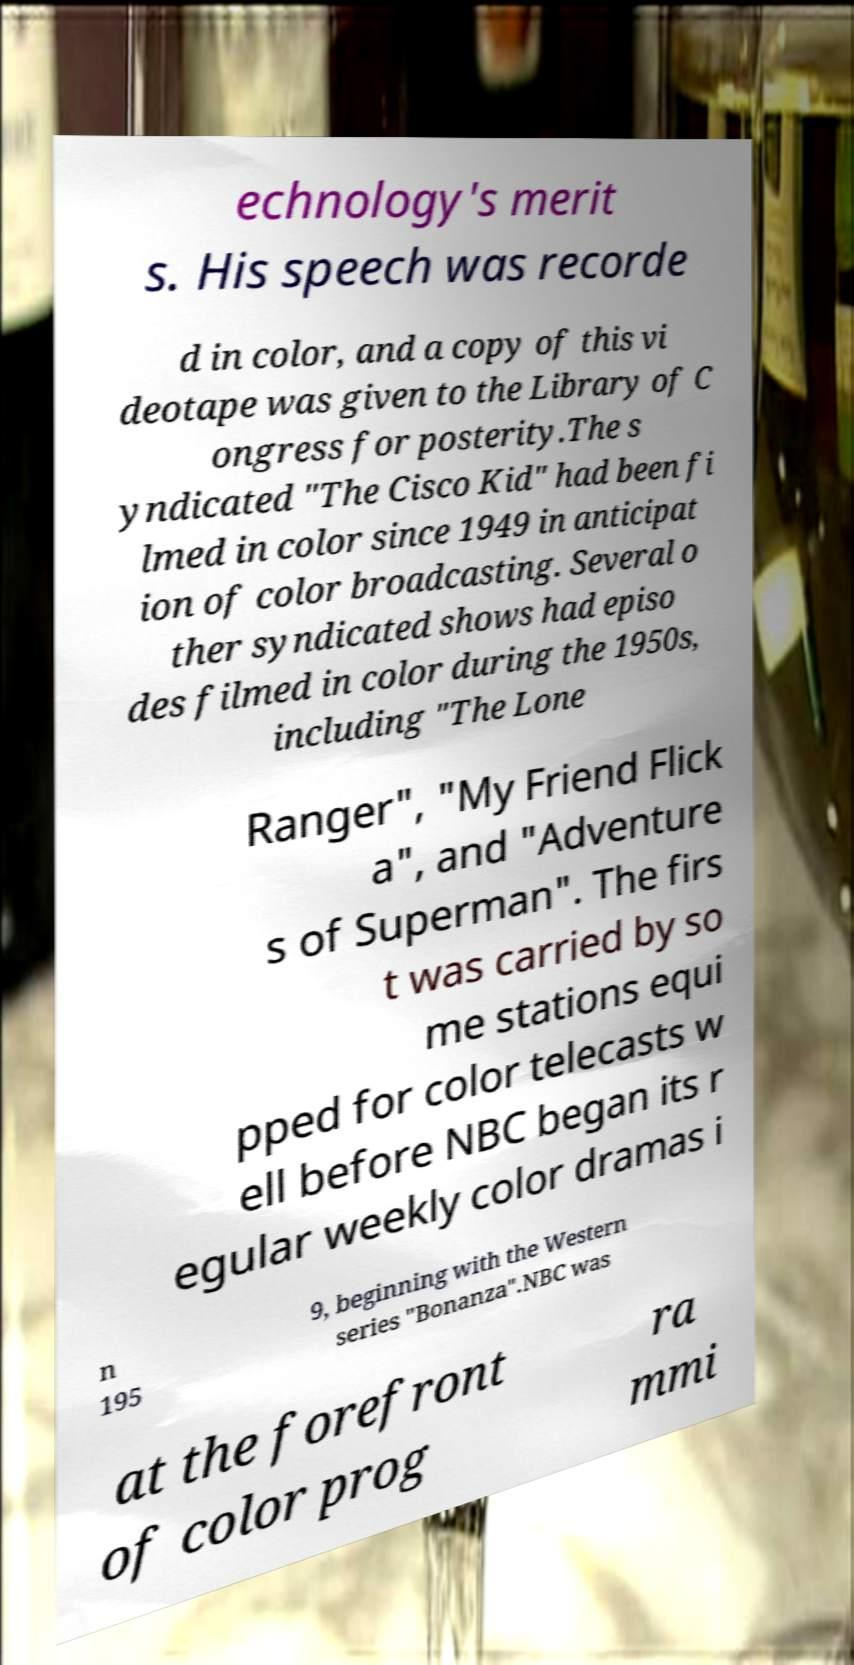Please read and relay the text visible in this image. What does it say? echnology's merit s. His speech was recorde d in color, and a copy of this vi deotape was given to the Library of C ongress for posterity.The s yndicated "The Cisco Kid" had been fi lmed in color since 1949 in anticipat ion of color broadcasting. Several o ther syndicated shows had episo des filmed in color during the 1950s, including "The Lone Ranger", "My Friend Flick a", and "Adventure s of Superman". The firs t was carried by so me stations equi pped for color telecasts w ell before NBC began its r egular weekly color dramas i n 195 9, beginning with the Western series "Bonanza".NBC was at the forefront of color prog ra mmi 